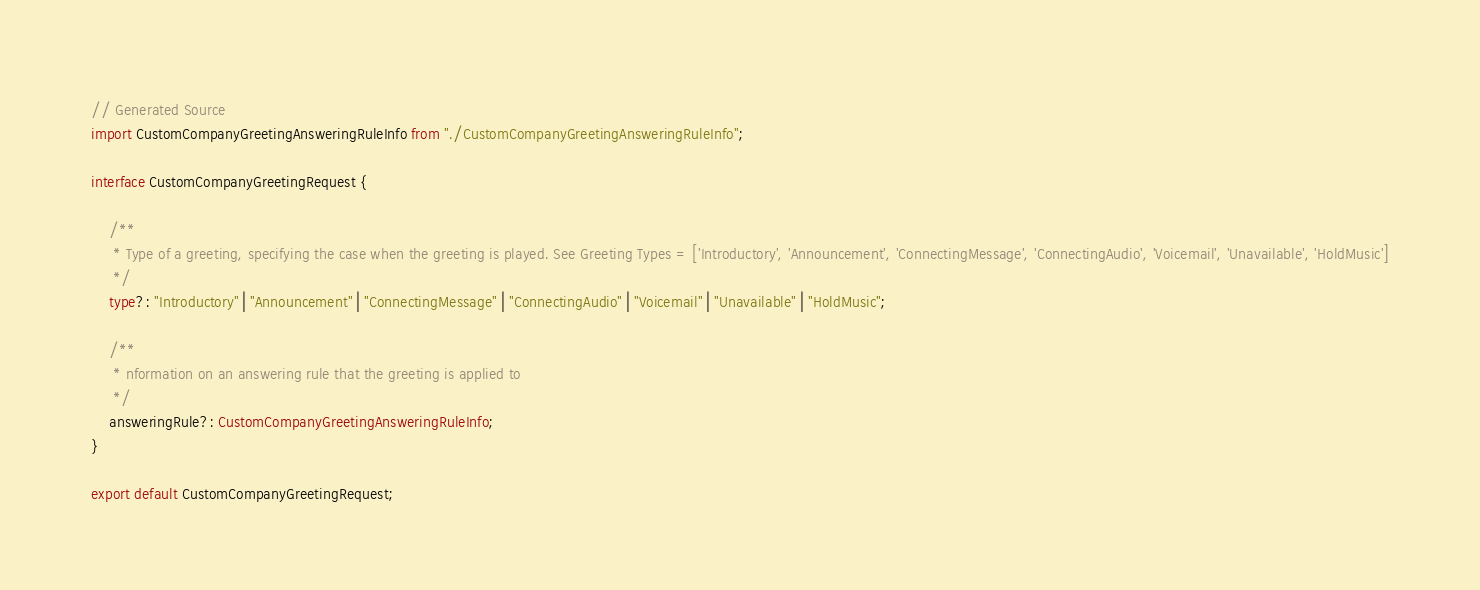<code> <loc_0><loc_0><loc_500><loc_500><_TypeScript_>// Generated Source
import CustomCompanyGreetingAnsweringRuleInfo from "./CustomCompanyGreetingAnsweringRuleInfo";

interface CustomCompanyGreetingRequest {

    /**
     * Type of a greeting, specifying the case when the greeting is played. See Greeting Types = ['Introductory', 'Announcement', 'ConnectingMessage', 'ConnectingAudio', 'Voicemail', 'Unavailable', 'HoldMusic']
     */
    type?: "Introductory" | "Announcement" | "ConnectingMessage" | "ConnectingAudio" | "Voicemail" | "Unavailable" | "HoldMusic";

    /**
     * nformation on an answering rule that the greeting is applied to
     */
    answeringRule?: CustomCompanyGreetingAnsweringRuleInfo;
}

export default CustomCompanyGreetingRequest;
</code> 